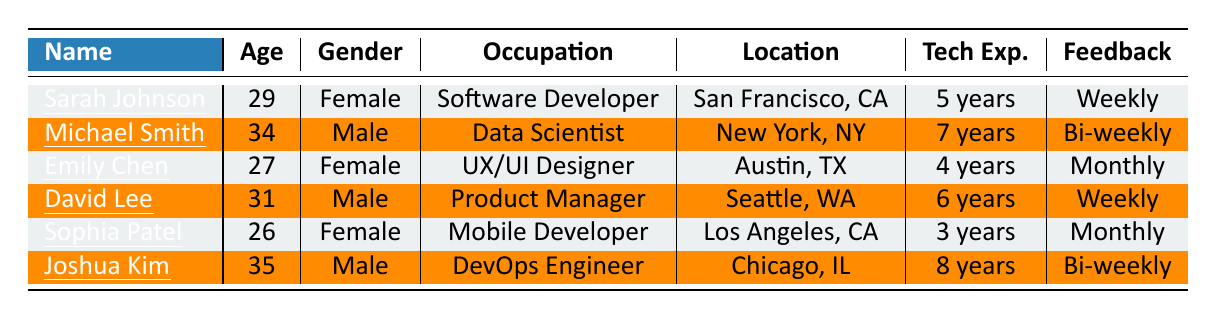What is the age of Sophia Patel? In the table, I find the row for Sophia Patel, and the age listed next to her name is 26.
Answer: 26 How many years of tech experience does Michael Smith have? Looking at Michael Smith's row, I see that he has 7 years of tech experience.
Answer: 7 years Which early adopter is located in New York, NY? By examining the locations in the table, I notice that Michael Smith is listed under New York, NY.
Answer: Michael Smith What feedback frequency does David Lee provide? The table shows that David Lee's feedback frequency is listed as "Weekly."
Answer: Weekly Is Emily Chen a Mobile Developer? I check the occupation of Emily Chen in the table, and I see she is a UX/UI Designer, not a Mobile Developer.
Answer: No Who has the highest tech experience among the early adopters? Comparing the tech experience listed for each individual, Joshua Kim has 8 years, which is the highest among the listed entries.
Answer: Joshua Kim Are there more male or female early adopters? Counting the genders in the table, there are three males (Michael Smith, David Lee, Joshua Kim) and three females (Sarah Johnson, Emily Chen, Sophia Patel), resulting in a tie.
Answer: Tie What is the average age of the early adopters? The ages are 29, 34, 27, 31, 26, and 35. Summing these gives 29 + 34 + 27 + 31 + 26 + 35 = 182. There are 6 adopters, so the average age is 182 / 6 = 30.33.
Answer: 30.33 Which two individuals have the same feedback frequency? On checking the feedback frequency, I find that Michael Smith and Joshua Kim both give feedback bi-weekly.
Answer: Michael Smith and Joshua Kim How many early adopters are from California? Looking at the locations, I find Sarah Johnson from San Francisco and Sophia Patel from Los Angeles, making it a total of two individuals from California.
Answer: 2 